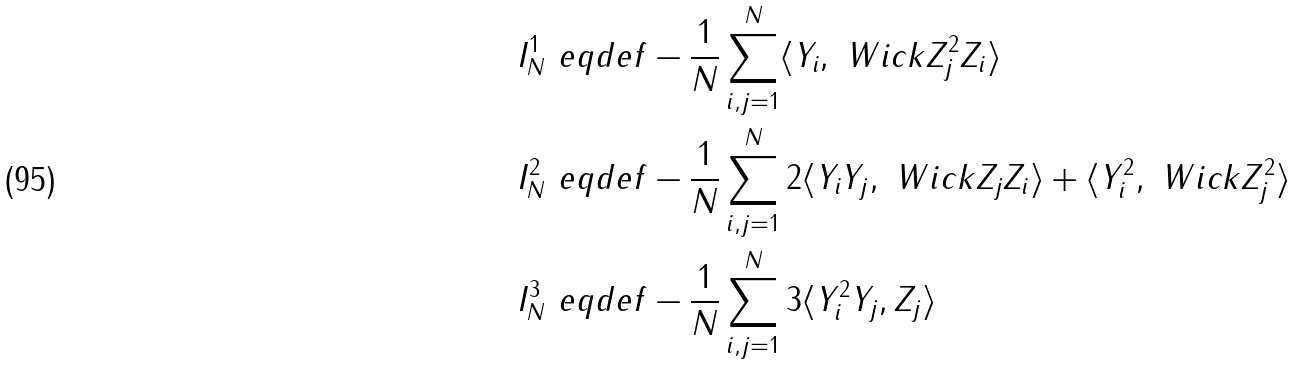Convert formula to latex. <formula><loc_0><loc_0><loc_500><loc_500>I _ { N } ^ { 1 } & \ e q d e f - \frac { 1 } { N } \sum _ { i , j = 1 } ^ { N } \langle Y _ { i } , \ W i c k { Z _ { j } ^ { 2 } Z _ { i } } \rangle \\ I _ { N } ^ { 2 } & \ e q d e f - \frac { 1 } { N } \sum _ { i , j = 1 } ^ { N } 2 \langle Y _ { i } Y _ { j } , \ W i c k { Z _ { j } Z _ { i } } \rangle + \langle Y _ { i } ^ { 2 } , \ W i c k { Z _ { j } ^ { 2 } } \rangle \\ I _ { N } ^ { 3 } & \ e q d e f - \frac { 1 } { N } \sum _ { i , j = 1 } ^ { N } 3 \langle Y _ { i } ^ { 2 } Y _ { j } , Z _ { j } \rangle</formula> 